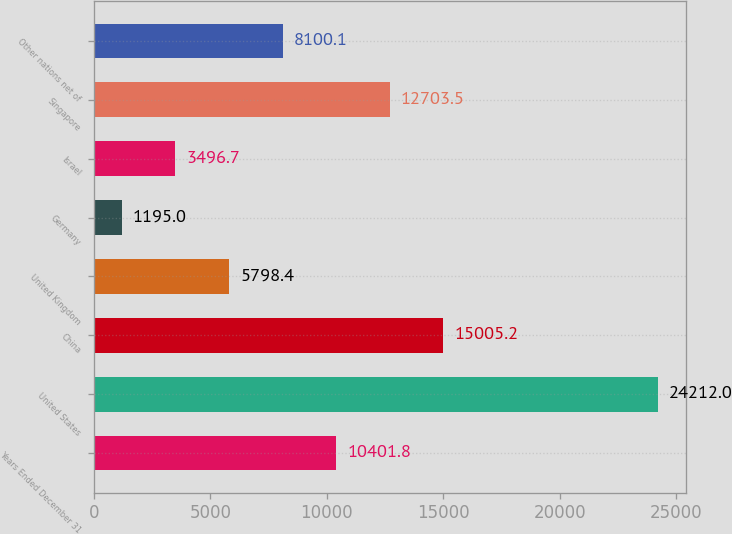Convert chart to OTSL. <chart><loc_0><loc_0><loc_500><loc_500><bar_chart><fcel>Years Ended December 31<fcel>United States<fcel>China<fcel>United Kingdom<fcel>Germany<fcel>Israel<fcel>Singapore<fcel>Other nations net of<nl><fcel>10401.8<fcel>24212<fcel>15005.2<fcel>5798.4<fcel>1195<fcel>3496.7<fcel>12703.5<fcel>8100.1<nl></chart> 